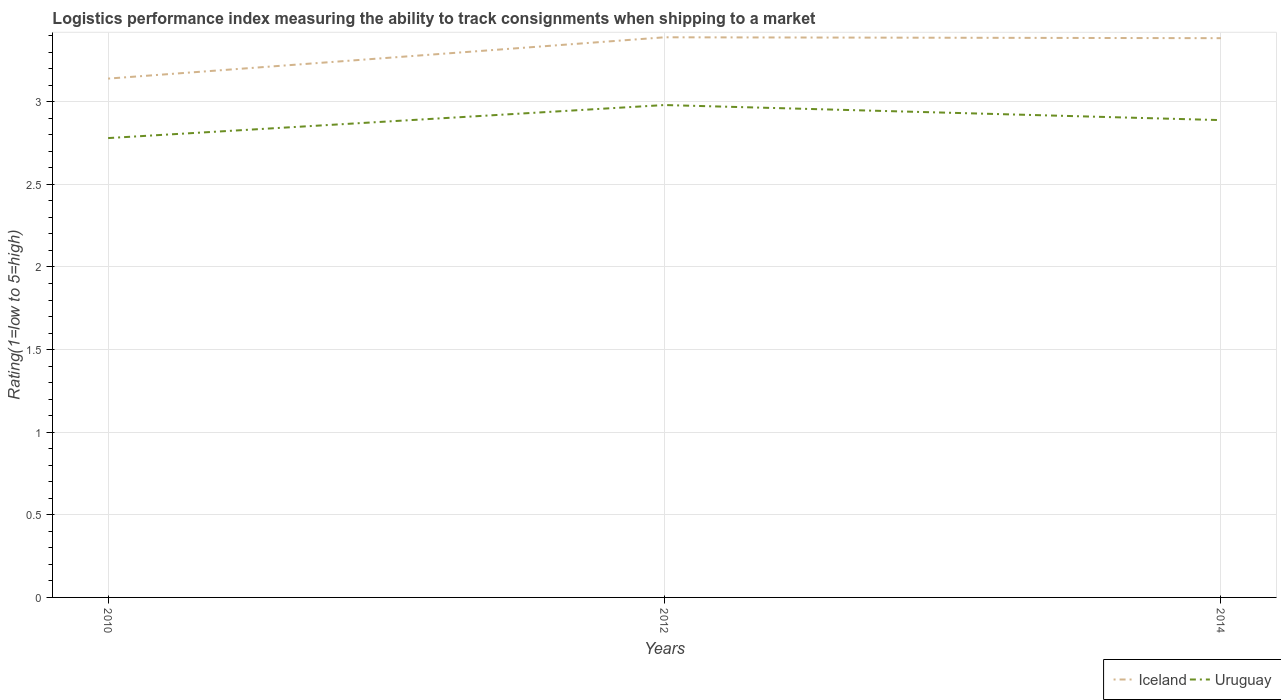How many different coloured lines are there?
Provide a succinct answer. 2. Does the line corresponding to Uruguay intersect with the line corresponding to Iceland?
Provide a short and direct response. No. Across all years, what is the maximum Logistic performance index in Uruguay?
Keep it short and to the point. 2.78. In which year was the Logistic performance index in Uruguay maximum?
Your answer should be very brief. 2010. What is the total Logistic performance index in Iceland in the graph?
Offer a very short reply. -0.24. What is the difference between the highest and the second highest Logistic performance index in Uruguay?
Your answer should be very brief. 0.2. What is the difference between two consecutive major ticks on the Y-axis?
Make the answer very short. 0.5. Are the values on the major ticks of Y-axis written in scientific E-notation?
Keep it short and to the point. No. Does the graph contain grids?
Your answer should be very brief. Yes. How are the legend labels stacked?
Provide a short and direct response. Horizontal. What is the title of the graph?
Keep it short and to the point. Logistics performance index measuring the ability to track consignments when shipping to a market. What is the label or title of the X-axis?
Offer a terse response. Years. What is the label or title of the Y-axis?
Keep it short and to the point. Rating(1=low to 5=high). What is the Rating(1=low to 5=high) of Iceland in 2010?
Your response must be concise. 3.14. What is the Rating(1=low to 5=high) of Uruguay in 2010?
Provide a succinct answer. 2.78. What is the Rating(1=low to 5=high) of Iceland in 2012?
Provide a short and direct response. 3.39. What is the Rating(1=low to 5=high) of Uruguay in 2012?
Provide a short and direct response. 2.98. What is the Rating(1=low to 5=high) in Iceland in 2014?
Provide a short and direct response. 3.38. What is the Rating(1=low to 5=high) of Uruguay in 2014?
Give a very brief answer. 2.89. Across all years, what is the maximum Rating(1=low to 5=high) in Iceland?
Your response must be concise. 3.39. Across all years, what is the maximum Rating(1=low to 5=high) in Uruguay?
Make the answer very short. 2.98. Across all years, what is the minimum Rating(1=low to 5=high) of Iceland?
Your response must be concise. 3.14. Across all years, what is the minimum Rating(1=low to 5=high) of Uruguay?
Offer a terse response. 2.78. What is the total Rating(1=low to 5=high) of Iceland in the graph?
Offer a very short reply. 9.91. What is the total Rating(1=low to 5=high) of Uruguay in the graph?
Make the answer very short. 8.65. What is the difference between the Rating(1=low to 5=high) of Uruguay in 2010 and that in 2012?
Offer a terse response. -0.2. What is the difference between the Rating(1=low to 5=high) in Iceland in 2010 and that in 2014?
Your response must be concise. -0.24. What is the difference between the Rating(1=low to 5=high) in Uruguay in 2010 and that in 2014?
Your response must be concise. -0.11. What is the difference between the Rating(1=low to 5=high) of Iceland in 2012 and that in 2014?
Ensure brevity in your answer.  0.01. What is the difference between the Rating(1=low to 5=high) of Uruguay in 2012 and that in 2014?
Offer a terse response. 0.09. What is the difference between the Rating(1=low to 5=high) of Iceland in 2010 and the Rating(1=low to 5=high) of Uruguay in 2012?
Ensure brevity in your answer.  0.16. What is the difference between the Rating(1=low to 5=high) in Iceland in 2010 and the Rating(1=low to 5=high) in Uruguay in 2014?
Your answer should be compact. 0.25. What is the difference between the Rating(1=low to 5=high) in Iceland in 2012 and the Rating(1=low to 5=high) in Uruguay in 2014?
Provide a succinct answer. 0.5. What is the average Rating(1=low to 5=high) of Iceland per year?
Your response must be concise. 3.3. What is the average Rating(1=low to 5=high) of Uruguay per year?
Offer a terse response. 2.88. In the year 2010, what is the difference between the Rating(1=low to 5=high) of Iceland and Rating(1=low to 5=high) of Uruguay?
Your answer should be very brief. 0.36. In the year 2012, what is the difference between the Rating(1=low to 5=high) of Iceland and Rating(1=low to 5=high) of Uruguay?
Make the answer very short. 0.41. In the year 2014, what is the difference between the Rating(1=low to 5=high) of Iceland and Rating(1=low to 5=high) of Uruguay?
Keep it short and to the point. 0.5. What is the ratio of the Rating(1=low to 5=high) of Iceland in 2010 to that in 2012?
Your answer should be compact. 0.93. What is the ratio of the Rating(1=low to 5=high) in Uruguay in 2010 to that in 2012?
Your answer should be very brief. 0.93. What is the ratio of the Rating(1=low to 5=high) of Iceland in 2010 to that in 2014?
Offer a terse response. 0.93. What is the ratio of the Rating(1=low to 5=high) of Uruguay in 2010 to that in 2014?
Provide a short and direct response. 0.96. What is the ratio of the Rating(1=low to 5=high) of Iceland in 2012 to that in 2014?
Offer a terse response. 1. What is the ratio of the Rating(1=low to 5=high) of Uruguay in 2012 to that in 2014?
Your answer should be compact. 1.03. What is the difference between the highest and the second highest Rating(1=low to 5=high) of Iceland?
Your answer should be compact. 0.01. What is the difference between the highest and the second highest Rating(1=low to 5=high) of Uruguay?
Ensure brevity in your answer.  0.09. 